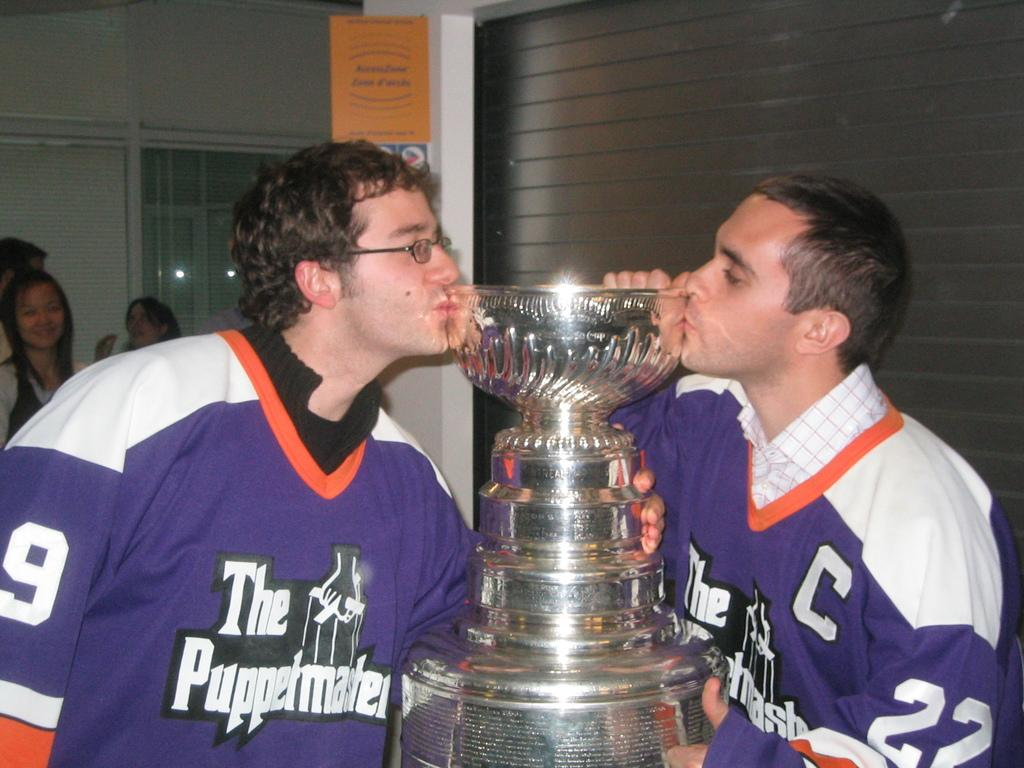Provide a one-sentence caption for the provided image. Two hockey players kissing a trophy, one of hem has C # 22, and the other on the left is # 9 for The Puppetmasters Team. 